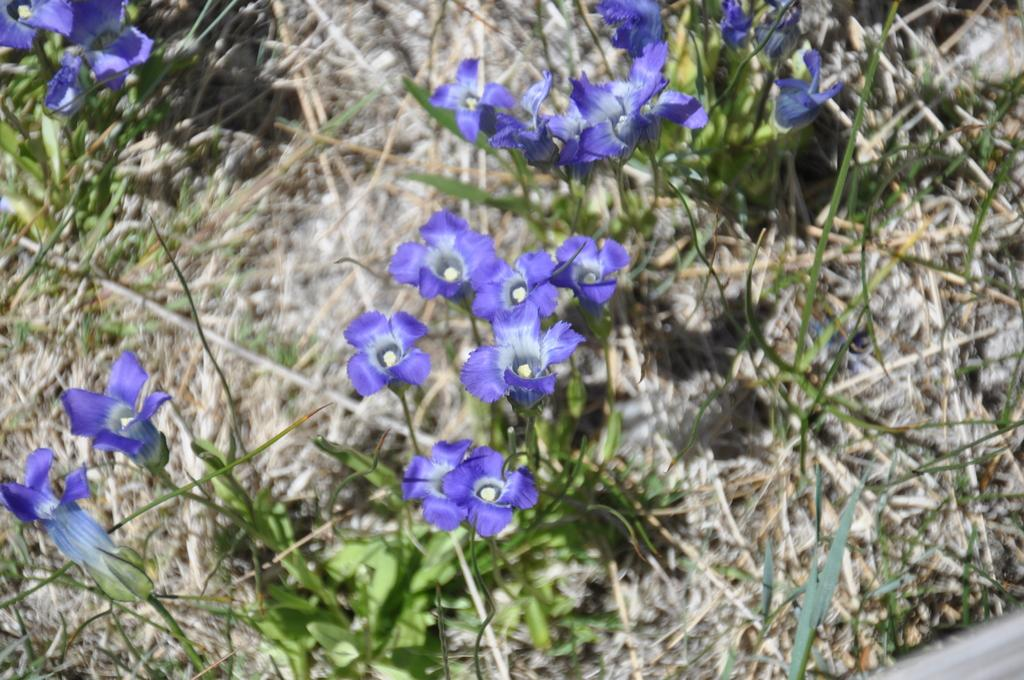What type of plants can be seen in the image? There are flowers in the image. What else can be seen in the image besides flowers? There is grass in the image. Reasoning: Let's think step by step by step in order to produce the conversation. We start by identifying the main subject in the image, which is the flowers. Then, we expand the conversation to include other elements that are also visible, such as the grass. Each question is designed to elicit a specific detail about the image that is known from the provided facts. Absurd Question/Answer: What type of pies are being served in the church depicted in the image? There is no church or pies present in the image; it only features flowers and grass. 